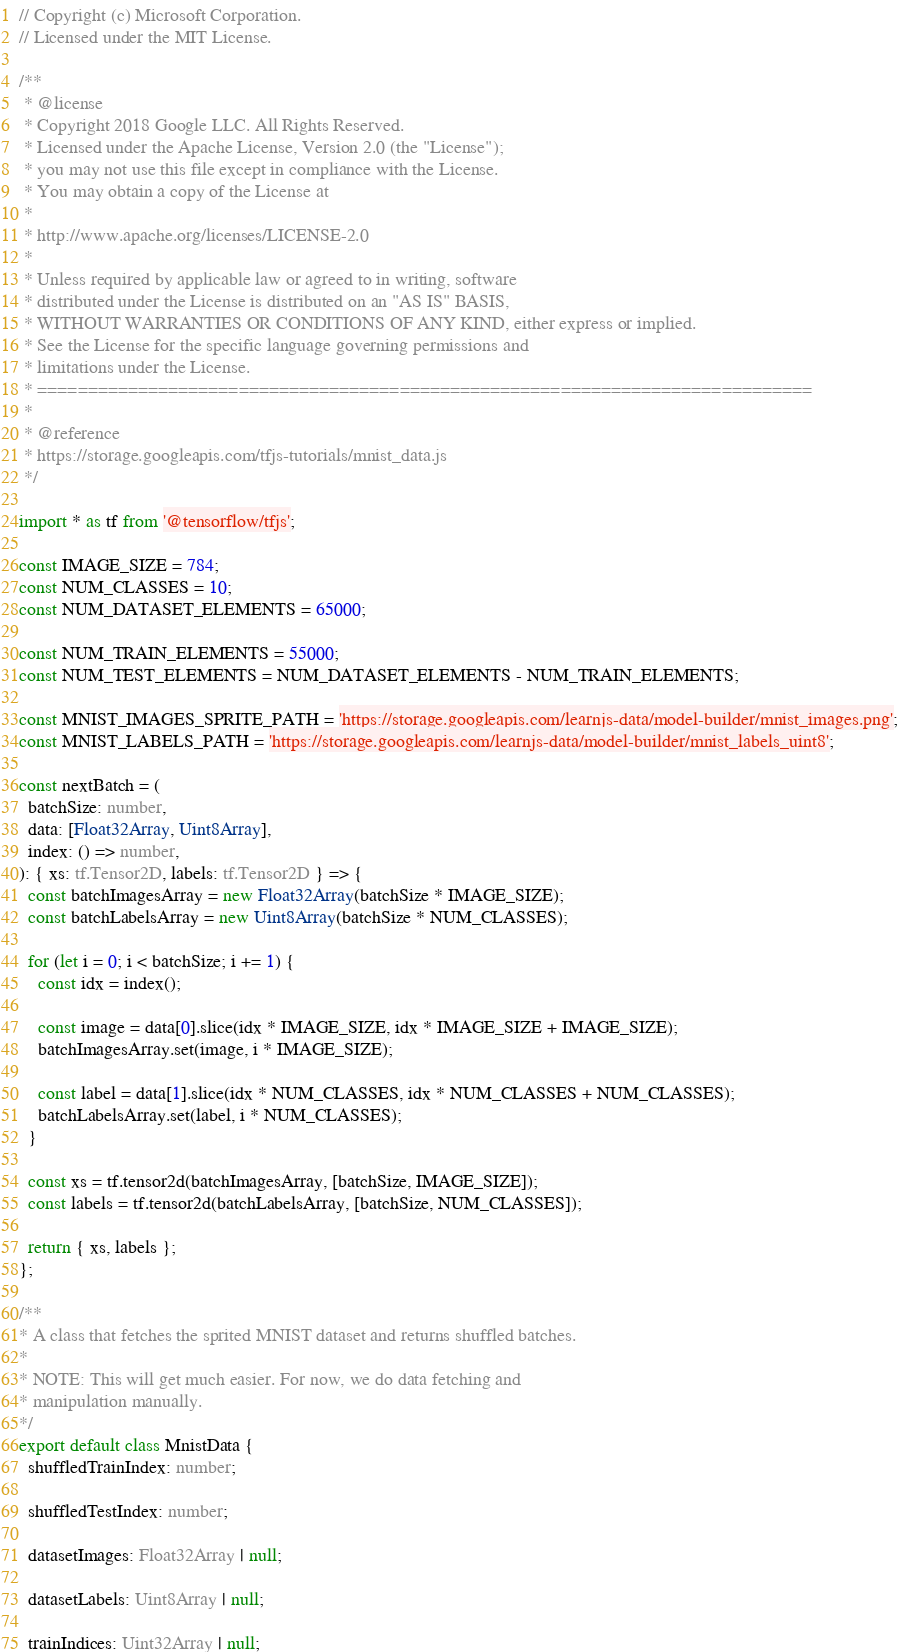<code> <loc_0><loc_0><loc_500><loc_500><_TypeScript_>// Copyright (c) Microsoft Corporation.
// Licensed under the MIT License.

/**
 * @license
 * Copyright 2018 Google LLC. All Rights Reserved.
 * Licensed under the Apache License, Version 2.0 (the "License");
 * you may not use this file except in compliance with the License.
 * You may obtain a copy of the License at
 *
 * http://www.apache.org/licenses/LICENSE-2.0
 *
 * Unless required by applicable law or agreed to in writing, software
 * distributed under the License is distributed on an "AS IS" BASIS,
 * WITHOUT WARRANTIES OR CONDITIONS OF ANY KIND, either express or implied.
 * See the License for the specific language governing permissions and
 * limitations under the License.
 * =============================================================================
 *
 * @reference
 * https://storage.googleapis.com/tfjs-tutorials/mnist_data.js
 */

import * as tf from '@tensorflow/tfjs';

const IMAGE_SIZE = 784;
const NUM_CLASSES = 10;
const NUM_DATASET_ELEMENTS = 65000;

const NUM_TRAIN_ELEMENTS = 55000;
const NUM_TEST_ELEMENTS = NUM_DATASET_ELEMENTS - NUM_TRAIN_ELEMENTS;

const MNIST_IMAGES_SPRITE_PATH = 'https://storage.googleapis.com/learnjs-data/model-builder/mnist_images.png';
const MNIST_LABELS_PATH = 'https://storage.googleapis.com/learnjs-data/model-builder/mnist_labels_uint8';

const nextBatch = (
  batchSize: number,
  data: [Float32Array, Uint8Array],
  index: () => number,
): { xs: tf.Tensor2D, labels: tf.Tensor2D } => {
  const batchImagesArray = new Float32Array(batchSize * IMAGE_SIZE);
  const batchLabelsArray = new Uint8Array(batchSize * NUM_CLASSES);

  for (let i = 0; i < batchSize; i += 1) {
    const idx = index();

    const image = data[0].slice(idx * IMAGE_SIZE, idx * IMAGE_SIZE + IMAGE_SIZE);
    batchImagesArray.set(image, i * IMAGE_SIZE);

    const label = data[1].slice(idx * NUM_CLASSES, idx * NUM_CLASSES + NUM_CLASSES);
    batchLabelsArray.set(label, i * NUM_CLASSES);
  }

  const xs = tf.tensor2d(batchImagesArray, [batchSize, IMAGE_SIZE]);
  const labels = tf.tensor2d(batchLabelsArray, [batchSize, NUM_CLASSES]);

  return { xs, labels };
};

/**
* A class that fetches the sprited MNIST dataset and returns shuffled batches.
*
* NOTE: This will get much easier. For now, we do data fetching and
* manipulation manually.
*/
export default class MnistData {
  shuffledTrainIndex: number;

  shuffledTestIndex: number;

  datasetImages: Float32Array | null;

  datasetLabels: Uint8Array | null;

  trainIndices: Uint32Array | null;
</code> 